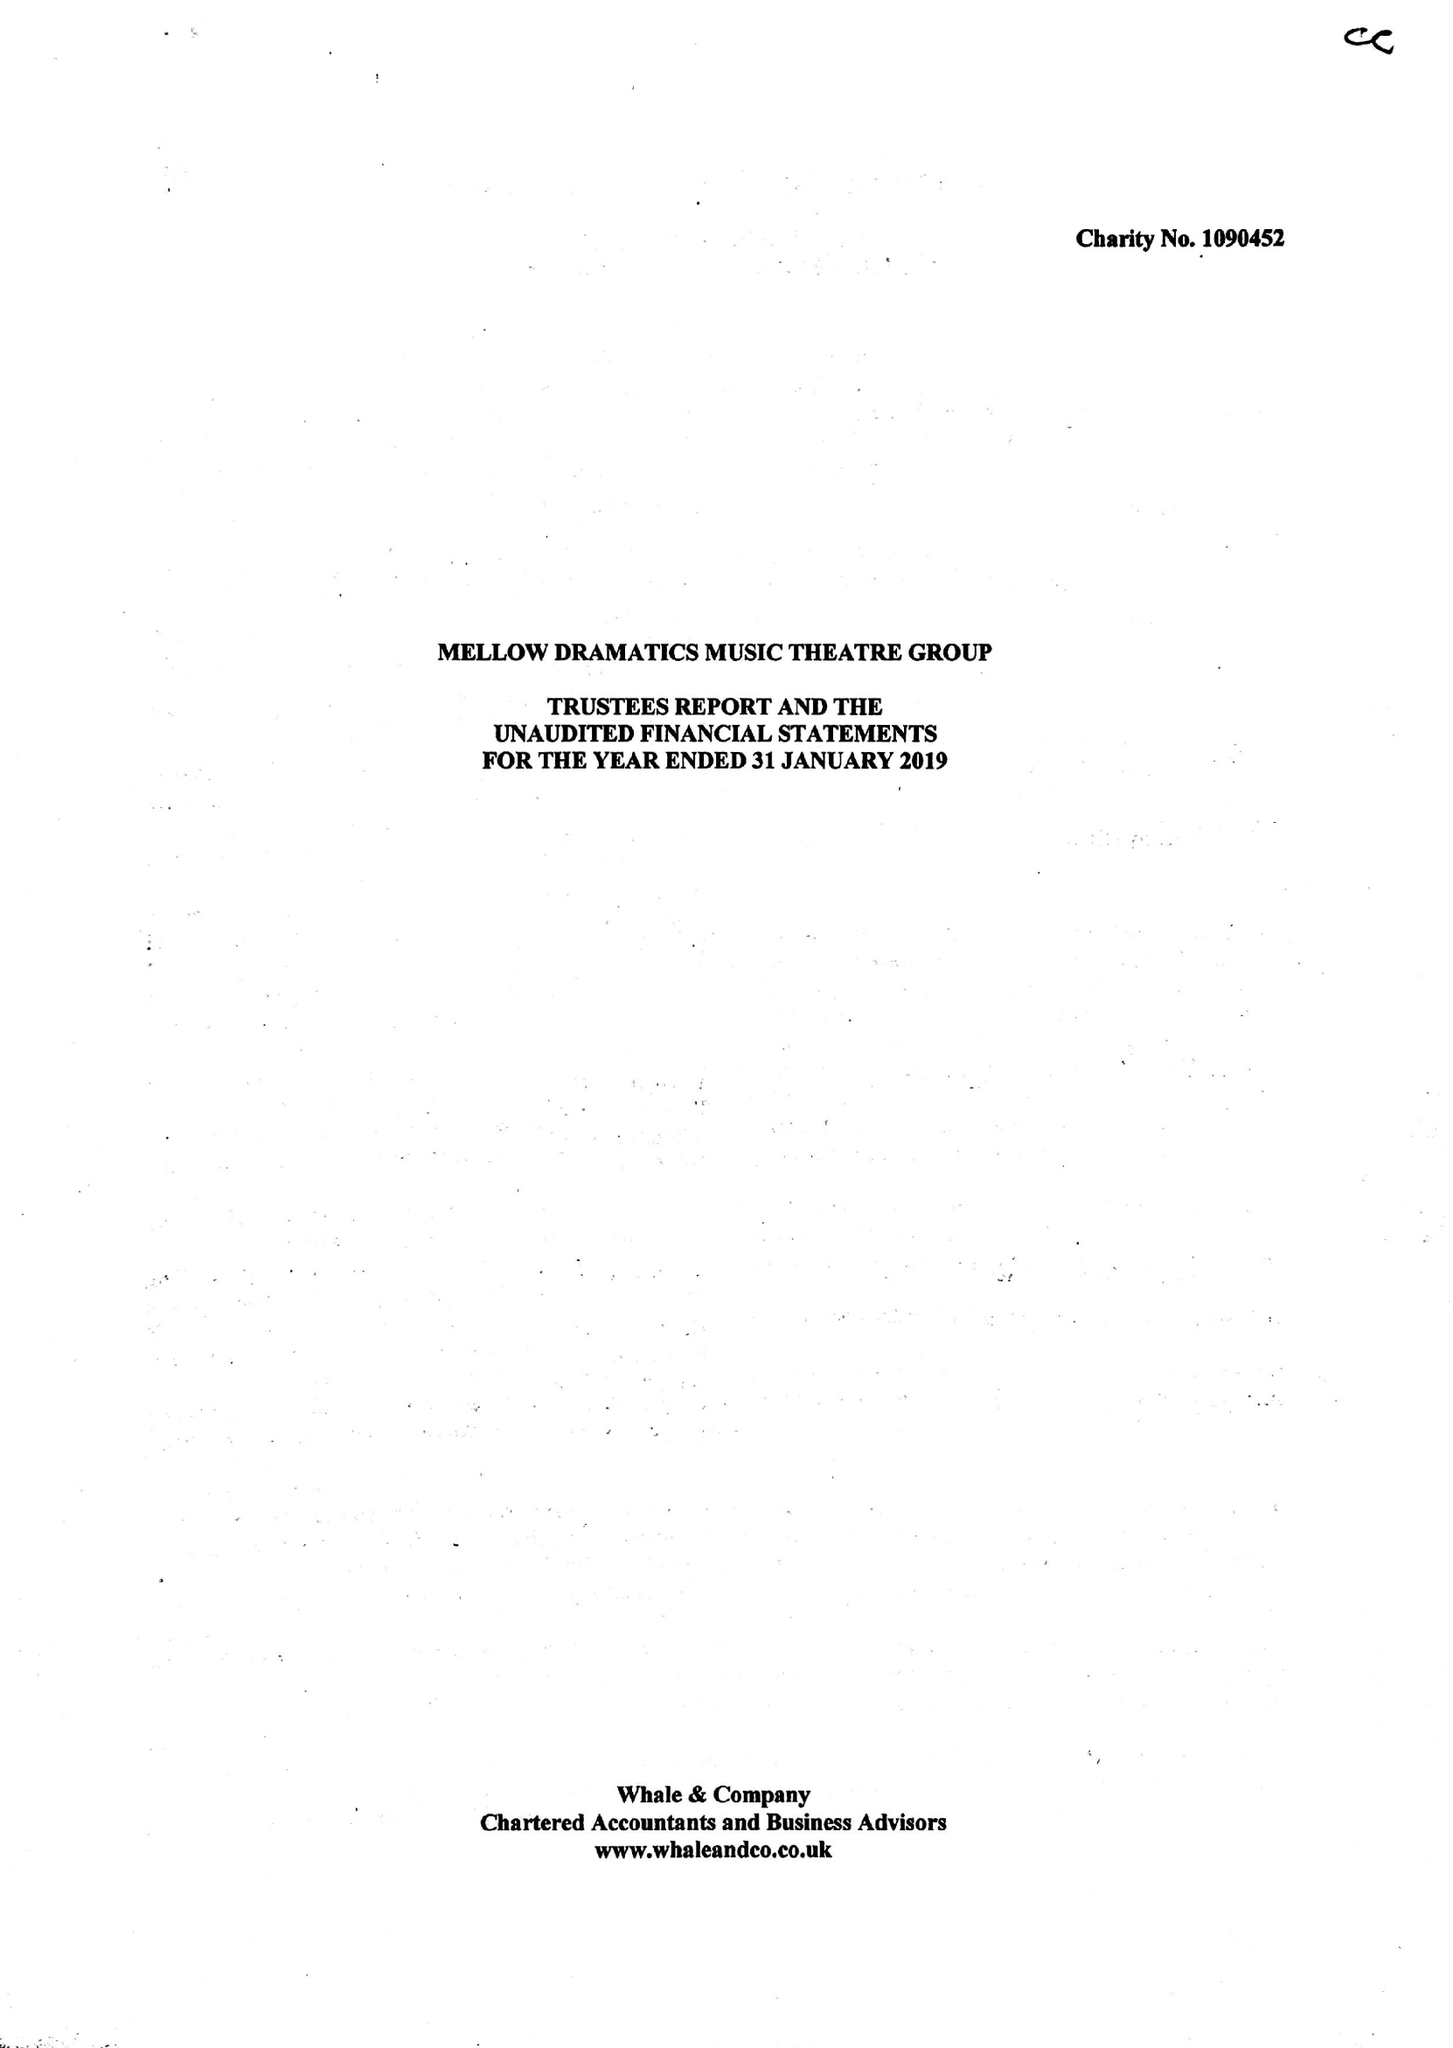What is the value for the income_annually_in_british_pounds?
Answer the question using a single word or phrase. 50229.00 